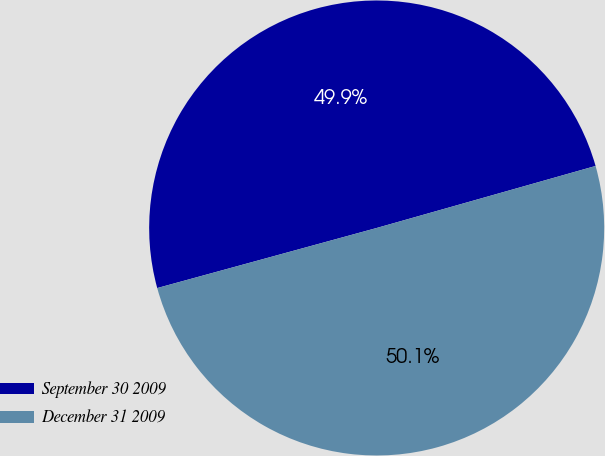Convert chart. <chart><loc_0><loc_0><loc_500><loc_500><pie_chart><fcel>September 30 2009<fcel>December 31 2009<nl><fcel>49.86%<fcel>50.14%<nl></chart> 